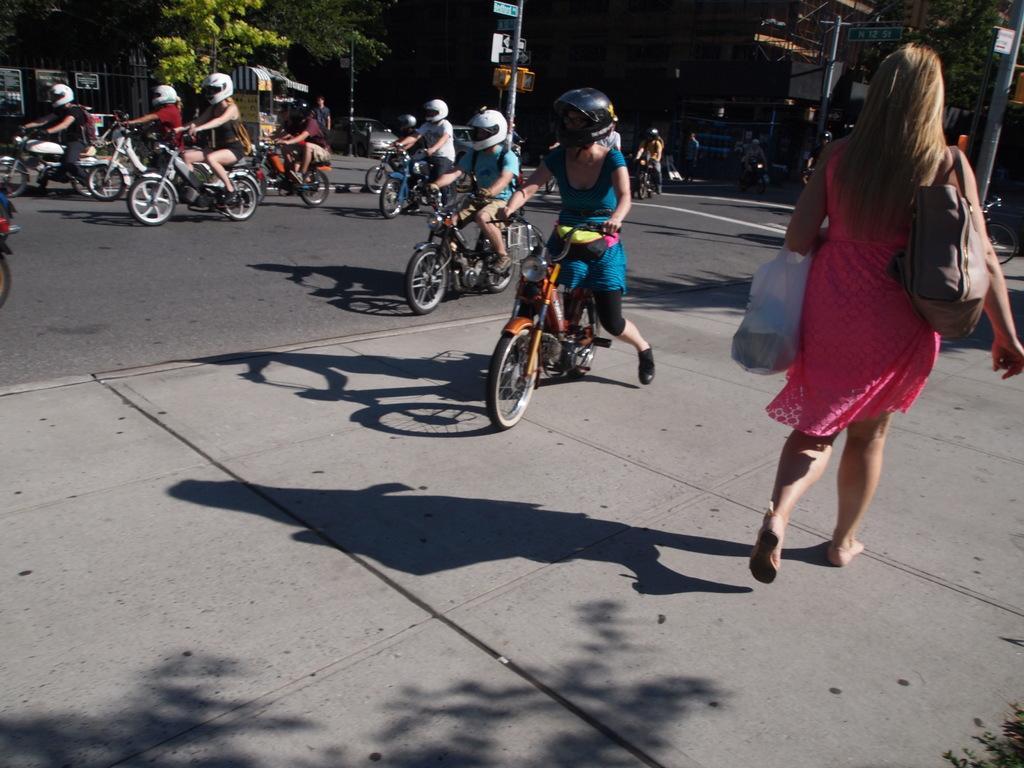Please provide a concise description of this image. There is one woman walking and holding a cover and a bag on the right side of this image. We can see people riding the bikes on the road as we can see in the middle of this image. There are trees and poles at the top of this image. 